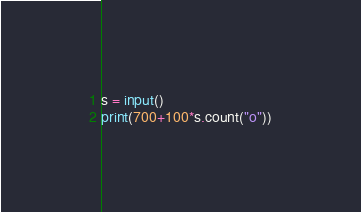<code> <loc_0><loc_0><loc_500><loc_500><_Python_>s = input()
print(700+100*s.count("o"))</code> 